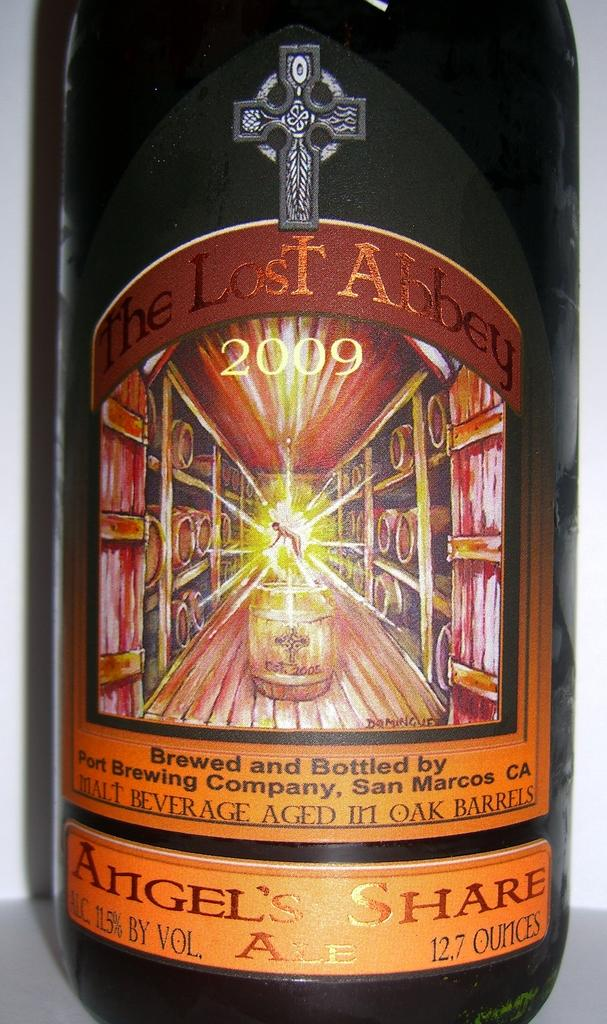Provide a one-sentence caption for the provided image. A bottled brew that is labelled "The Lost Abbey". 